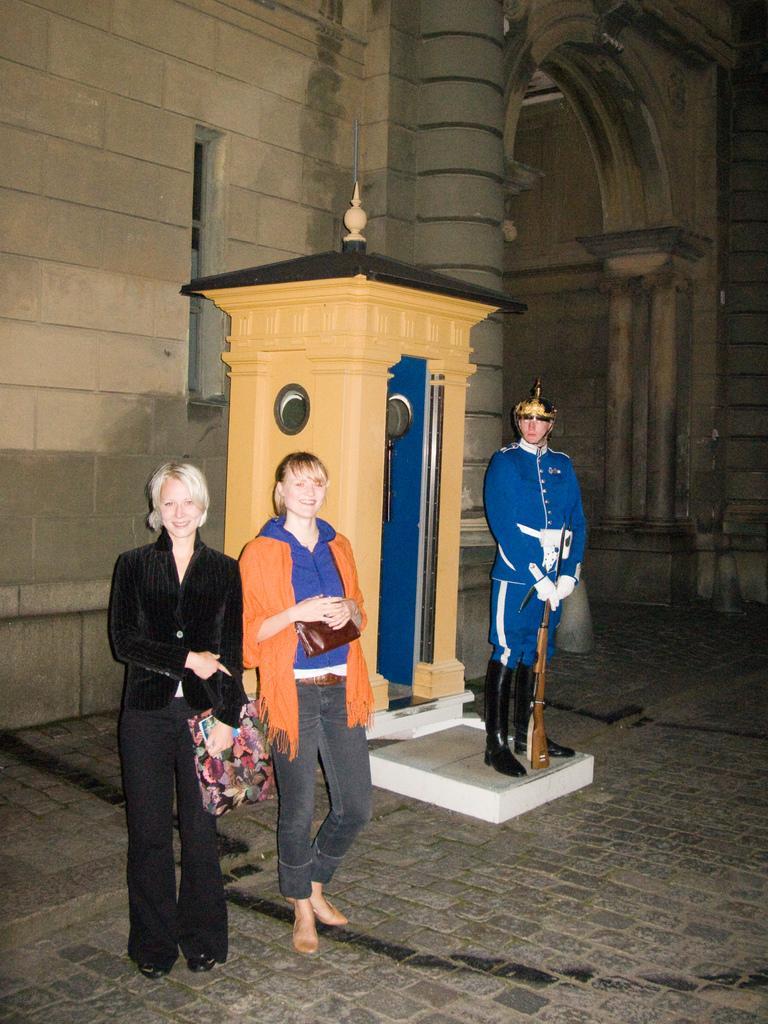How would you summarize this image in a sentence or two? In this picture we can see there are three people standing and a person in the blue dress is holding a gun. Behind the person, it looks like an architecture. Behind the people there is a building. 